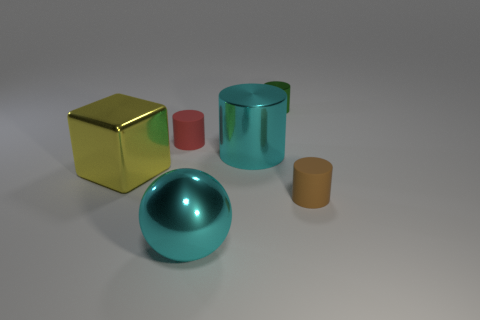Add 2 shiny things. How many objects exist? 8 Subtract all blocks. How many objects are left? 5 Subtract 0 green blocks. How many objects are left? 6 Subtract all brown things. Subtract all tiny cylinders. How many objects are left? 2 Add 4 tiny green metallic objects. How many tiny green metallic objects are left? 5 Add 4 small red matte blocks. How many small red matte blocks exist? 4 